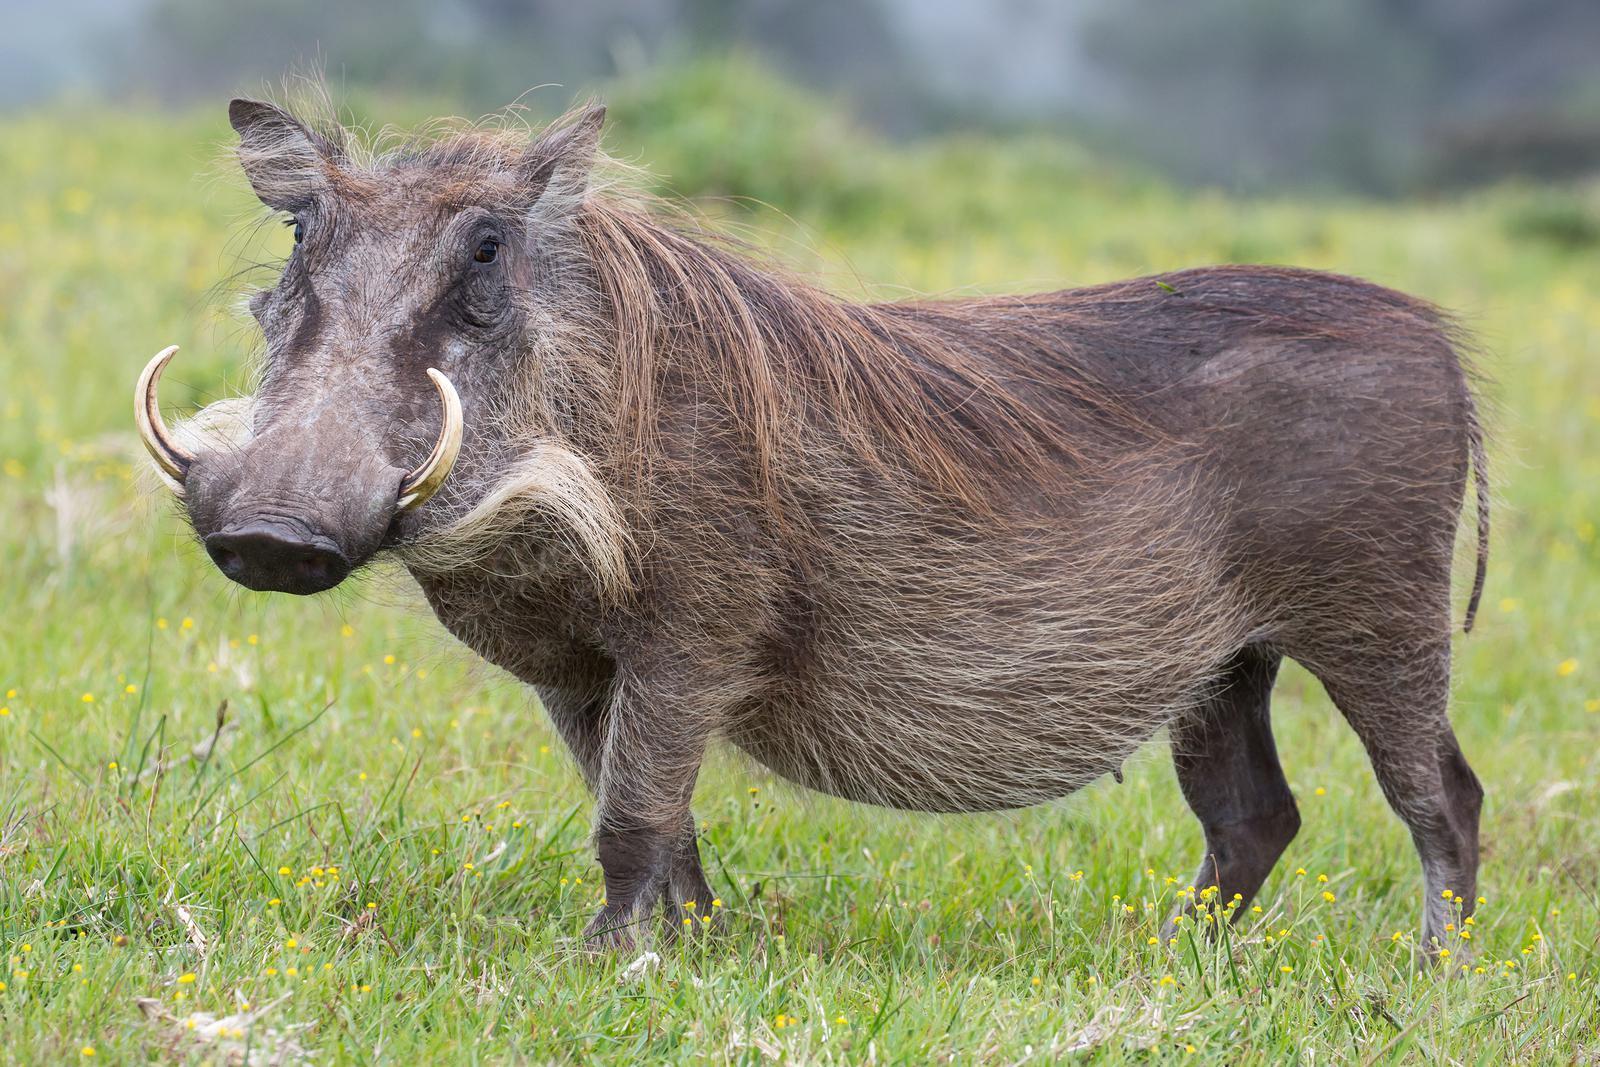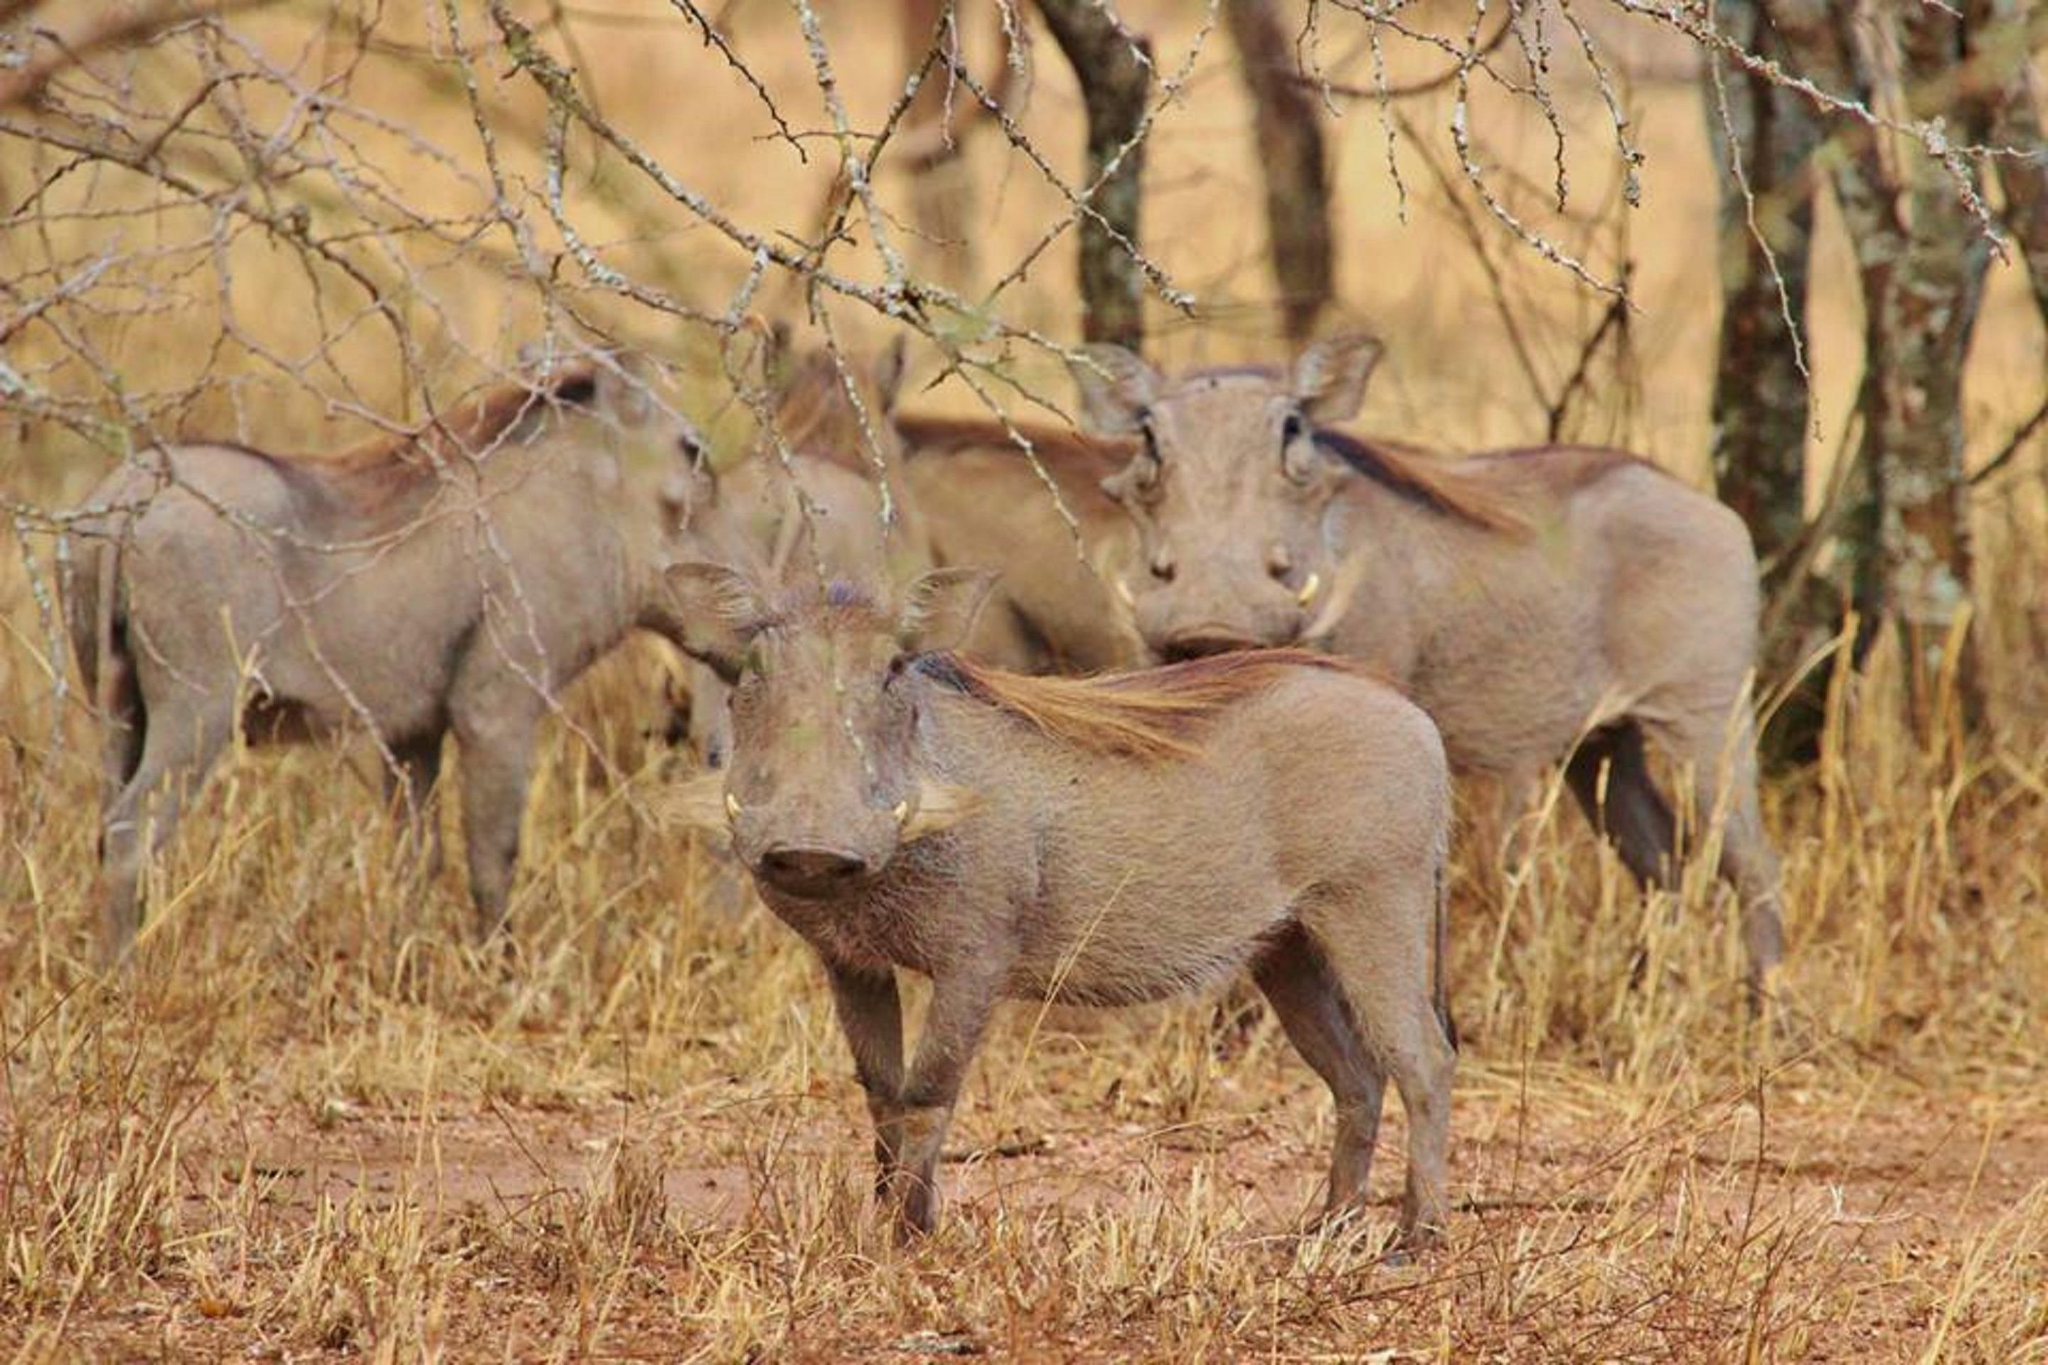The first image is the image on the left, the second image is the image on the right. Evaluate the accuracy of this statement regarding the images: "One image shows exactly one pair of similarly-posed warthogs in a mostly brown scene.". Is it true? Answer yes or no. No. The first image is the image on the left, the second image is the image on the right. Considering the images on both sides, is "The right image contains exactly two warthogs." valid? Answer yes or no. No. 